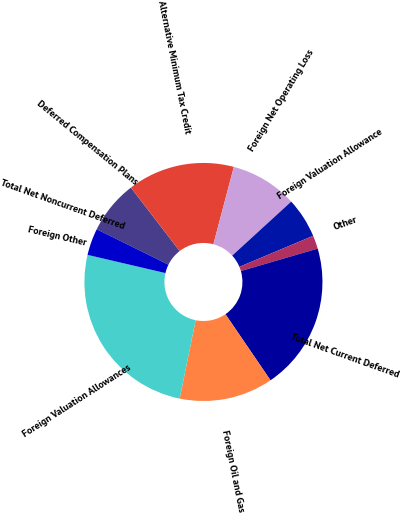Convert chart. <chart><loc_0><loc_0><loc_500><loc_500><pie_chart><fcel>Deferred Compensation Plans<fcel>Alternative Minimum Tax Credit<fcel>Foreign Net Operating Loss<fcel>Foreign Valuation Allowance<fcel>Other<fcel>Total Net Current Deferred<fcel>Foreign Oil and Gas<fcel>Foreign Valuation Allowances<fcel>Foreign Other<fcel>Total Net Noncurrent Deferred<nl><fcel>7.27%<fcel>14.54%<fcel>9.09%<fcel>5.46%<fcel>1.82%<fcel>19.99%<fcel>12.73%<fcel>25.45%<fcel>0.01%<fcel>3.64%<nl></chart> 